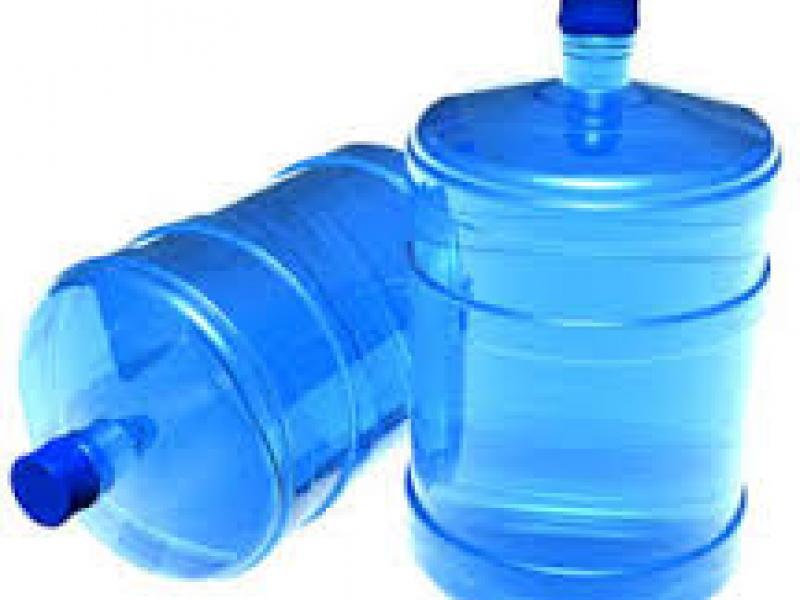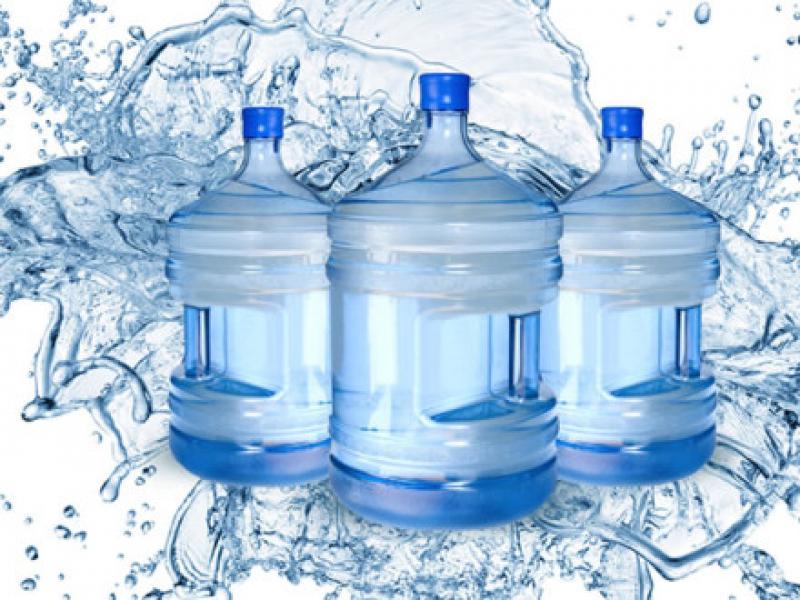The first image is the image on the left, the second image is the image on the right. Analyze the images presented: Is the assertion "There are less than three bottles in the left image." valid? Answer yes or no. Yes. The first image is the image on the left, the second image is the image on the right. Examine the images to the left and right. Is the description "The left image contains no more than one upright water jug, and the right image includes only upright jugs with blue caps." accurate? Answer yes or no. Yes. 